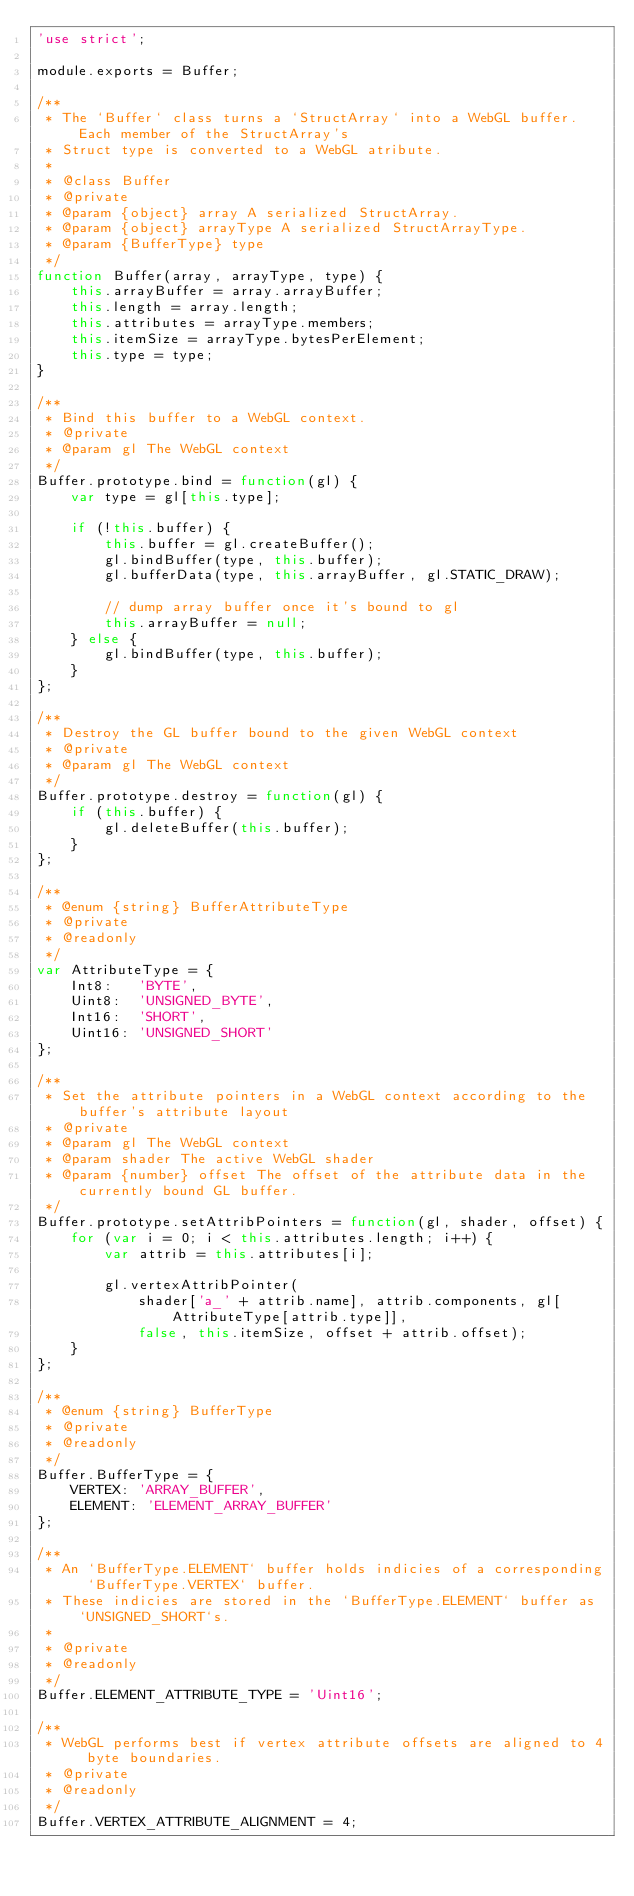Convert code to text. <code><loc_0><loc_0><loc_500><loc_500><_JavaScript_>'use strict';

module.exports = Buffer;

/**
 * The `Buffer` class turns a `StructArray` into a WebGL buffer. Each member of the StructArray's
 * Struct type is converted to a WebGL atribute.
 *
 * @class Buffer
 * @private
 * @param {object} array A serialized StructArray.
 * @param {object} arrayType A serialized StructArrayType.
 * @param {BufferType} type
 */
function Buffer(array, arrayType, type) {
    this.arrayBuffer = array.arrayBuffer;
    this.length = array.length;
    this.attributes = arrayType.members;
    this.itemSize = arrayType.bytesPerElement;
    this.type = type;
}

/**
 * Bind this buffer to a WebGL context.
 * @private
 * @param gl The WebGL context
 */
Buffer.prototype.bind = function(gl) {
    var type = gl[this.type];

    if (!this.buffer) {
        this.buffer = gl.createBuffer();
        gl.bindBuffer(type, this.buffer);
        gl.bufferData(type, this.arrayBuffer, gl.STATIC_DRAW);

        // dump array buffer once it's bound to gl
        this.arrayBuffer = null;
    } else {
        gl.bindBuffer(type, this.buffer);
    }
};

/**
 * Destroy the GL buffer bound to the given WebGL context
 * @private
 * @param gl The WebGL context
 */
Buffer.prototype.destroy = function(gl) {
    if (this.buffer) {
        gl.deleteBuffer(this.buffer);
    }
};

/**
 * @enum {string} BufferAttributeType
 * @private
 * @readonly
 */
var AttributeType = {
    Int8:   'BYTE',
    Uint8:  'UNSIGNED_BYTE',
    Int16:  'SHORT',
    Uint16: 'UNSIGNED_SHORT'
};

/**
 * Set the attribute pointers in a WebGL context according to the buffer's attribute layout
 * @private
 * @param gl The WebGL context
 * @param shader The active WebGL shader
 * @param {number} offset The offset of the attribute data in the currently bound GL buffer.
 */
Buffer.prototype.setAttribPointers = function(gl, shader, offset) {
    for (var i = 0; i < this.attributes.length; i++) {
        var attrib = this.attributes[i];

        gl.vertexAttribPointer(
            shader['a_' + attrib.name], attrib.components, gl[AttributeType[attrib.type]],
            false, this.itemSize, offset + attrib.offset);
    }
};

/**
 * @enum {string} BufferType
 * @private
 * @readonly
 */
Buffer.BufferType = {
    VERTEX: 'ARRAY_BUFFER',
    ELEMENT: 'ELEMENT_ARRAY_BUFFER'
};

/**
 * An `BufferType.ELEMENT` buffer holds indicies of a corresponding `BufferType.VERTEX` buffer.
 * These indicies are stored in the `BufferType.ELEMENT` buffer as `UNSIGNED_SHORT`s.
 *
 * @private
 * @readonly
 */
Buffer.ELEMENT_ATTRIBUTE_TYPE = 'Uint16';

/**
 * WebGL performs best if vertex attribute offsets are aligned to 4 byte boundaries.
 * @private
 * @readonly
 */
Buffer.VERTEX_ATTRIBUTE_ALIGNMENT = 4;
</code> 